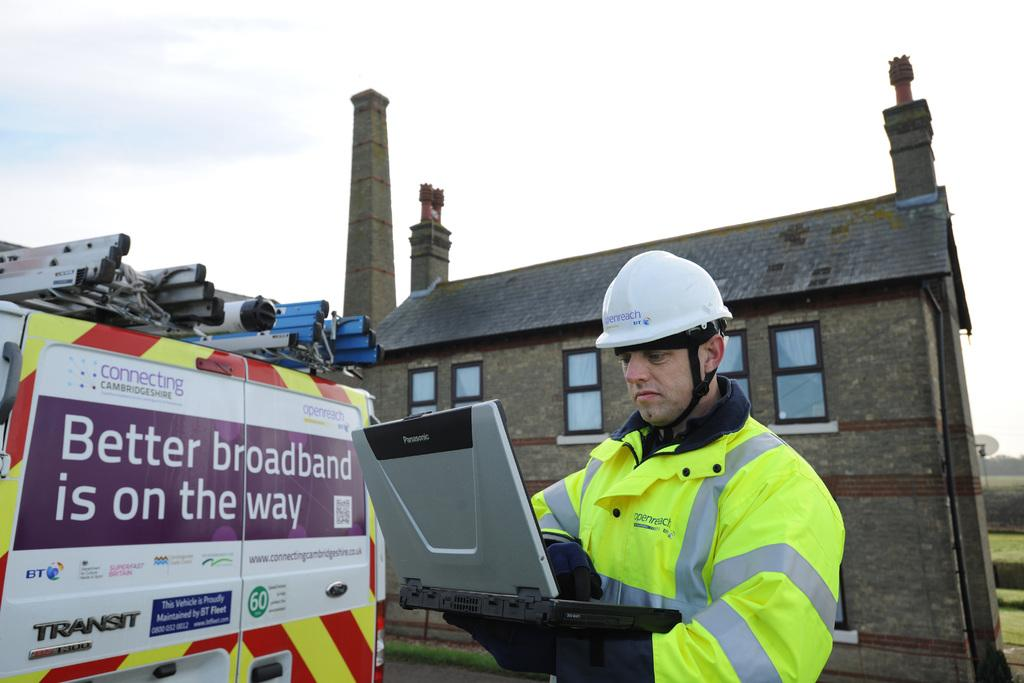Who is the main subject in the image? There is a man in the image. What is the man doing in the image? The man is standing and operating a laptop. What can be seen in the background of the image? There are buildings and plants in the backdrop of the image. What is the condition of the sky in the image? The sky is clear in the image. How many chairs are visible in the image? There are no chairs visible in the image. Is the man saying good-bye to someone in the image? There is no indication in the image that the man is saying good-bye to someone. 